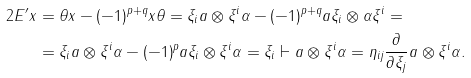<formula> <loc_0><loc_0><loc_500><loc_500>2 E ^ { \prime } x & = \theta x - ( - 1 ) ^ { p + q } x \theta = \xi _ { i } a \otimes \xi ^ { i } \alpha - ( - 1 ) ^ { p + q } a \xi _ { i } \otimes \alpha \xi ^ { i } = \\ & = \xi _ { i } a \otimes \xi ^ { i } \alpha - ( - 1 ) ^ { p } a \xi _ { i } \otimes \xi ^ { i } \alpha = \xi _ { i } \vdash a \otimes \xi ^ { i } \alpha = \eta _ { i j } \frac { \partial } { \partial \xi _ { j } } a \otimes \xi ^ { i } \alpha .</formula> 